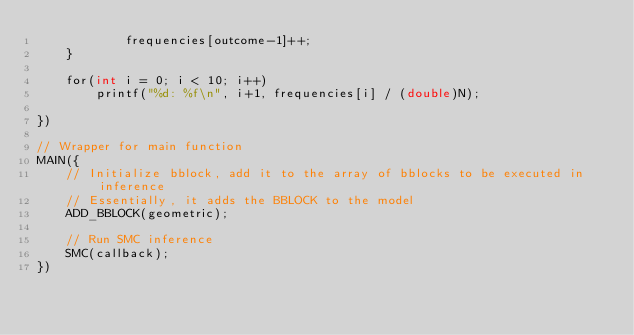Convert code to text. <code><loc_0><loc_0><loc_500><loc_500><_Cuda_>            frequencies[outcome-1]++;
    }

    for(int i = 0; i < 10; i++)
        printf("%d: %f\n", i+1, frequencies[i] / (double)N);

})

// Wrapper for main function
MAIN({
    // Initialize bblock, add it to the array of bblocks to be executed in inference
    // Essentially, it adds the BBLOCK to the model
    ADD_BBLOCK(geometric);

    // Run SMC inference
    SMC(callback);
})
</code> 